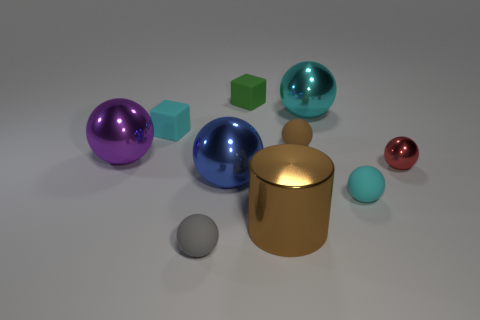Is the small shiny thing the same color as the cylinder?
Offer a very short reply. No. What number of small metal things are on the right side of the brown ball?
Ensure brevity in your answer.  1. There is a small thing that is the same material as the large cyan thing; what is its color?
Your response must be concise. Red. How many matte objects are either cyan balls or big brown cylinders?
Give a very brief answer. 1. Does the red object have the same material as the tiny green cube?
Provide a succinct answer. No. There is a small cyan rubber object that is left of the big brown object; what is its shape?
Give a very brief answer. Cube. There is a shiny object that is behind the big purple metallic object; is there a big metallic sphere behind it?
Your answer should be compact. No. Is there a red metal thing of the same size as the brown matte thing?
Keep it short and to the point. Yes. There is a big metallic thing to the right of the big cylinder; is its color the same as the metal cylinder?
Make the answer very short. No. How big is the cyan metal sphere?
Your response must be concise. Large. 